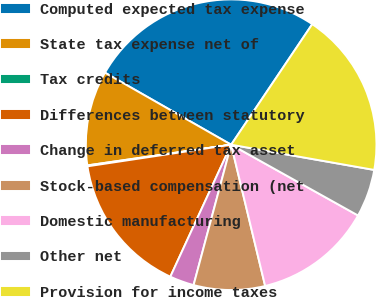<chart> <loc_0><loc_0><loc_500><loc_500><pie_chart><fcel>Computed expected tax expense<fcel>State tax expense net of<fcel>Tax credits<fcel>Differences between statutory<fcel>Change in deferred tax asset<fcel>Stock-based compensation (net<fcel>Domestic manufacturing<fcel>Other net<fcel>Provision for income taxes<nl><fcel>26.17%<fcel>10.53%<fcel>0.1%<fcel>15.75%<fcel>2.71%<fcel>7.92%<fcel>13.14%<fcel>5.32%<fcel>18.35%<nl></chart> 